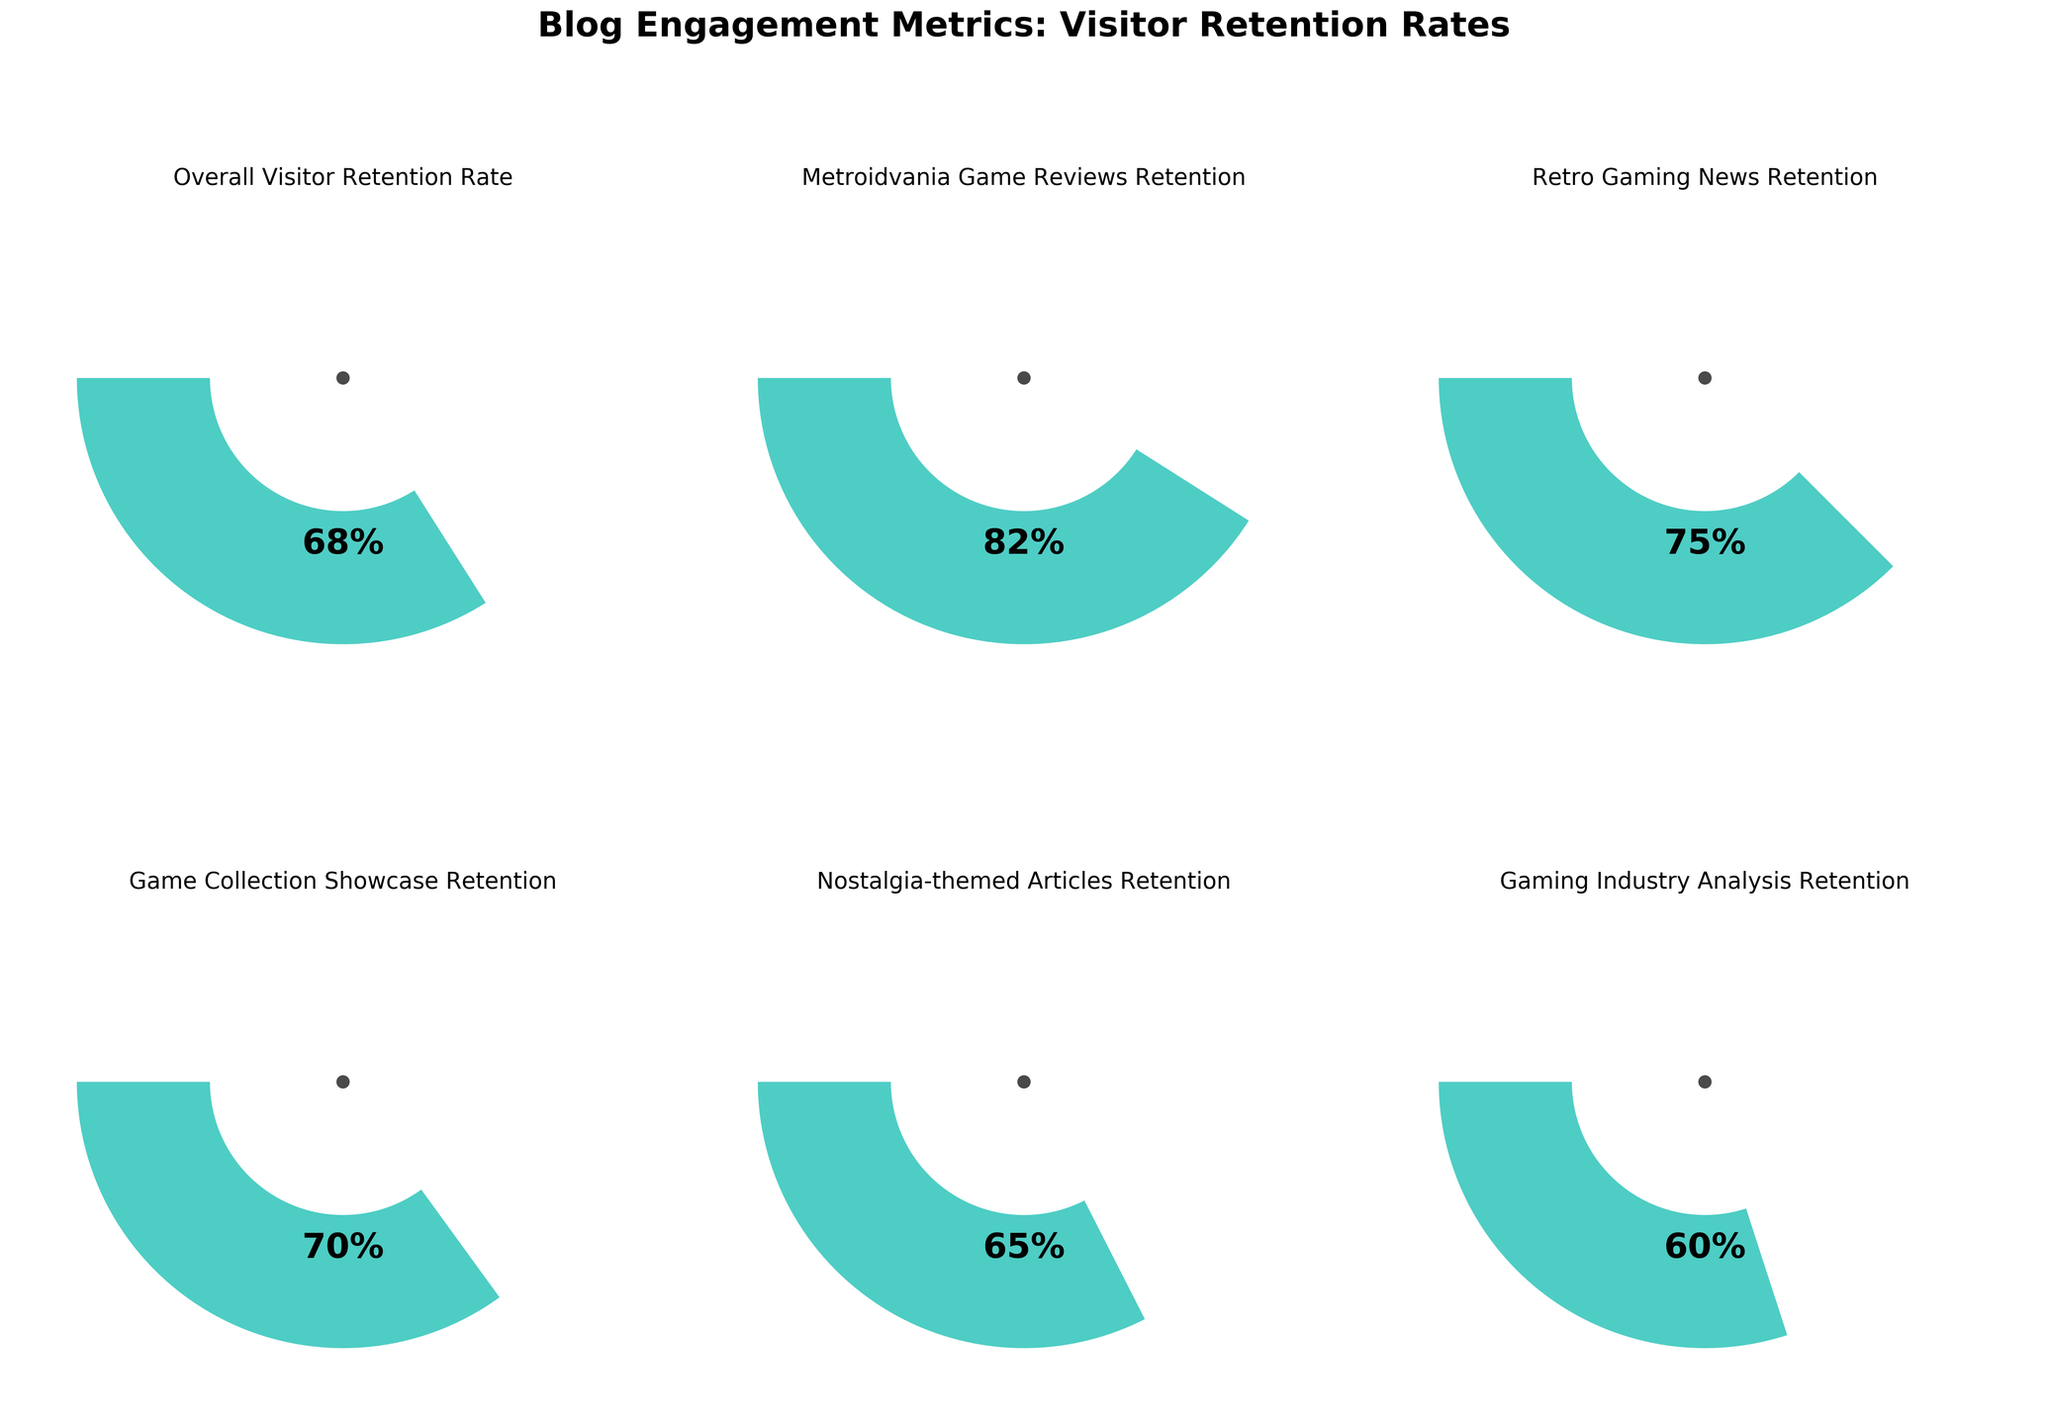What is the overall visitor retention rate for the blog? The overall visitor retention rate is directly stated on the gauge chart for "Overall Visitor Retention Rate." The value shown is 68%.
Answer: 68% Which category has the highest visitor retention rate? Compare the values for all categories. The gauge chart for "Metroidvania Game Reviews Retention" shows the highest retention rate at 82%.
Answer: Metroidvania Game Reviews Retention What is the difference in retention rate between "Retro Gaming News Retention" and "Gaming Industry Analysis Retention"? Subtract the retention rate for "Gaming Industry Analysis Retention" (60%) from "Retro Gaming News Retention" (75%). The difference is 75% - 60% = 15%.
Answer: 15% What is the average retention rate across all categories? Sum the retention rates for all categories and divide by the number of categories: (68 + 82 + 75 + 70 + 65 + 60) / 6 = 70%.
Answer: 70% Which category has the lowest visitor retention rate? Compare the values for all categories. The gauge chart for "Gaming Industry Analysis Retention" shows the lowest retention rate at 60%.
Answer: Gaming Industry Analysis Retention How does the retention rate for "Nostalgia-themed Articles Retention" compare to the overall visitor retention rate? The retention rate for "Nostalgia-themed Articles Retention" is 65%, and the overall visitor retention rate is 68%. "Nostalgia-themed Articles Retention" is lower than the overall rate.
Answer: Lower Arrange the categories in descending order of visitor retention rates. List the categories and their retention rates: "Metroidvania Game Reviews Retention" (82%), "Retro Gaming News Retention" (75%), "Game Collection Showcase Retention" (70%), "Nostalgia-themed Articles Retention" (65%), "Gaming Industry Analysis Retention" (60%).
Answer: Metroidvania Game Reviews Retention, Retro Gaming News Retention, Game Collection Showcase Retention, Nostalgia-themed Articles Retention, Gaming Industry Analysis Retention 